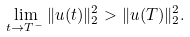Convert formula to latex. <formula><loc_0><loc_0><loc_500><loc_500>\lim _ { t \to T ^ { - } } \| u ( t ) \| _ { 2 } ^ { 2 } > \| u ( T ) \| _ { 2 } ^ { 2 } .</formula> 